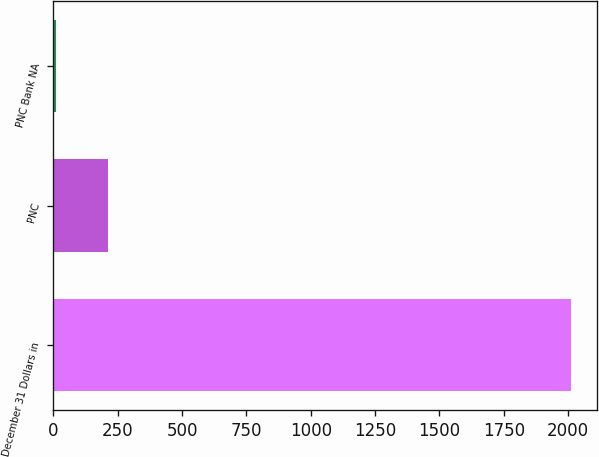Convert chart. <chart><loc_0><loc_0><loc_500><loc_500><bar_chart><fcel>December 31 Dollars in<fcel>PNC<fcel>PNC Bank NA<nl><fcel>2011<fcel>211.36<fcel>11.4<nl></chart> 